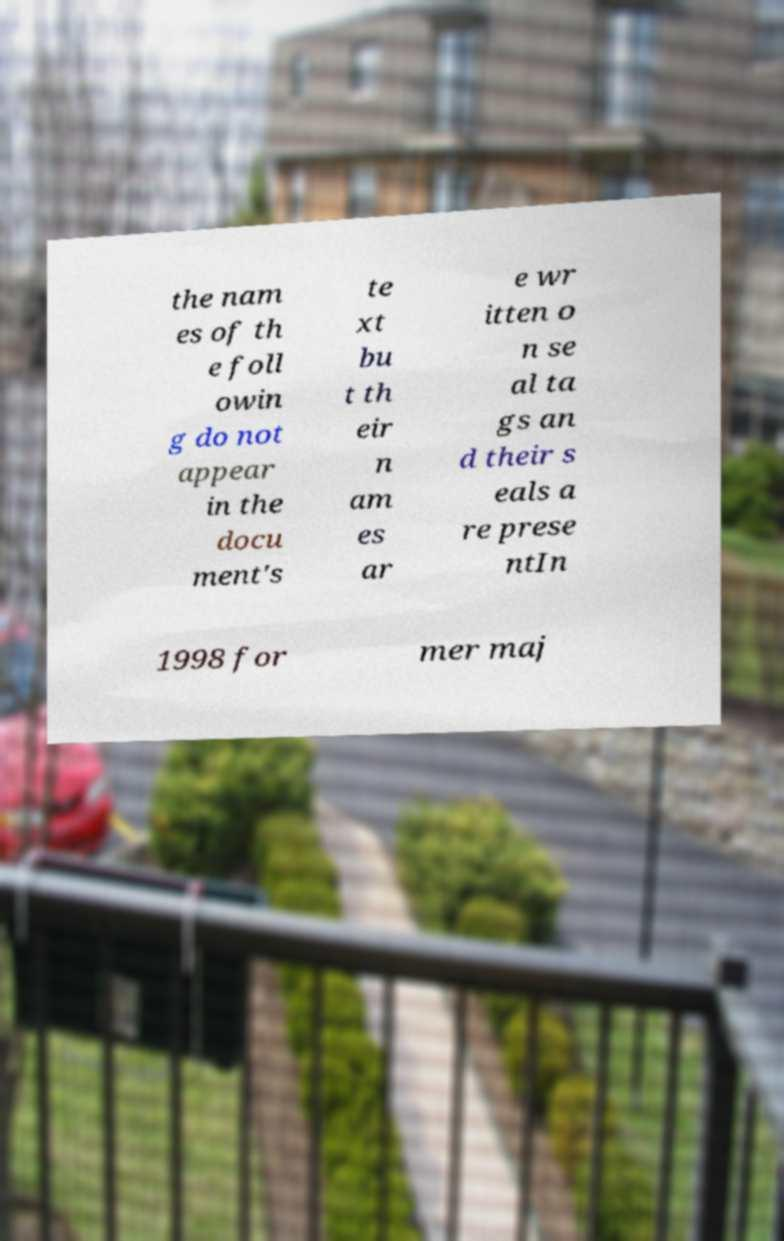Could you assist in decoding the text presented in this image and type it out clearly? the nam es of th e foll owin g do not appear in the docu ment's te xt bu t th eir n am es ar e wr itten o n se al ta gs an d their s eals a re prese ntIn 1998 for mer maj 